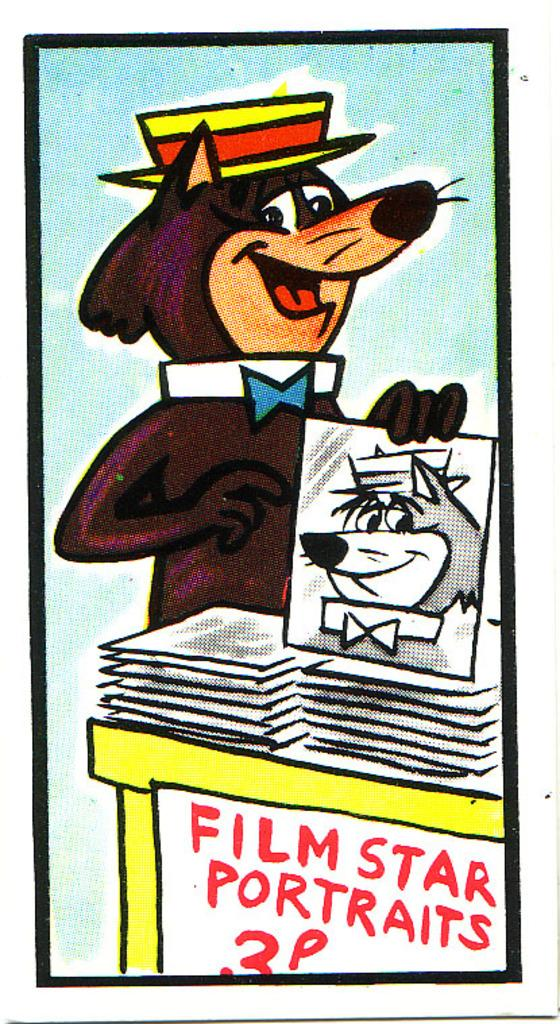<image>
Describe the image concisely. A cartoon picture of a bear at a Film Star portraits stand. 